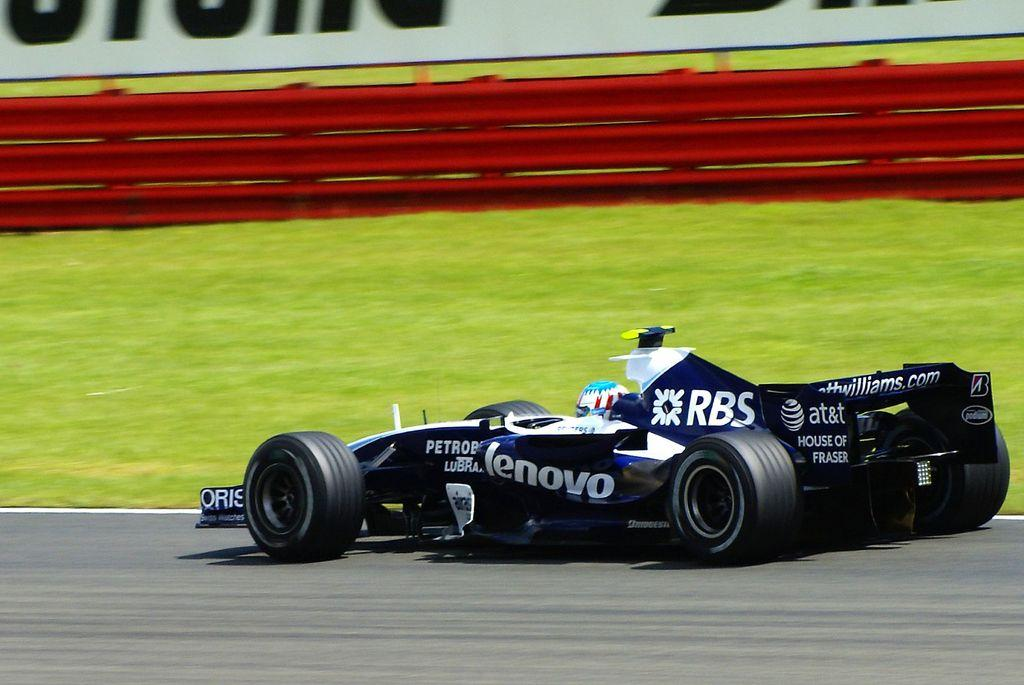What type of vehicle is in the image? There is an F1 car in the image. What color is the F1 car? The F1 car is black in color. What is the F1 car doing in the image? The F1 car is moving on a track. What can be seen in the background of the image? There is grass and red color fencing visible in the background of the image. What grade does the F1 car receive for its performance in the image? There is no grade given for the F1 car's performance in the image, as it is a still image and not a performance evaluation. 